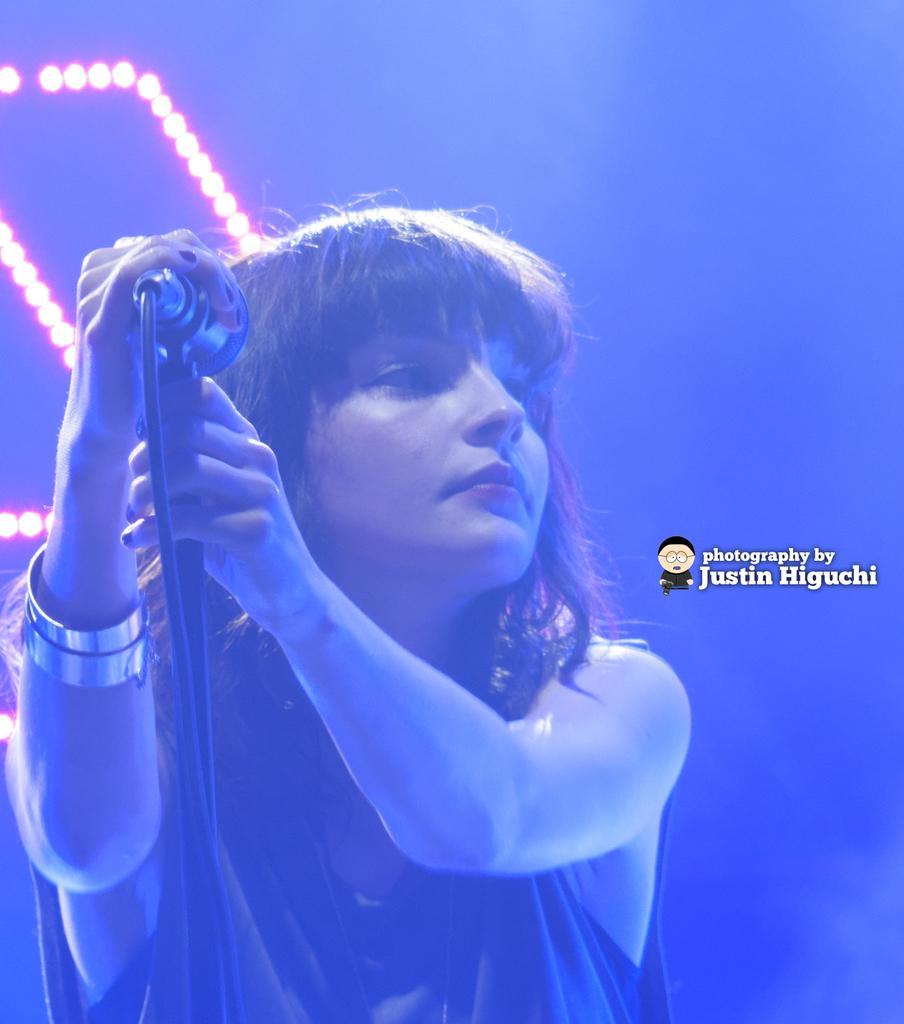Who is the main subject in the image? There is a woman in the image. Where is the woman positioned in the image? The woman is standing in the middle of the image. What is the woman holding in the image? The woman is holding a microphone. What can be seen behind the woman in the image? There are lights visible behind the woman. What type of screw is being used to hold the carriage together in the image? There is no carriage or screw present in the image; it features a woman holding a microphone with lights behind her. Can you recite the verse that the woman is singing in the image? There is no indication in the image that the woman is singing or reciting a verse, so it cannot be determined from the picture. 